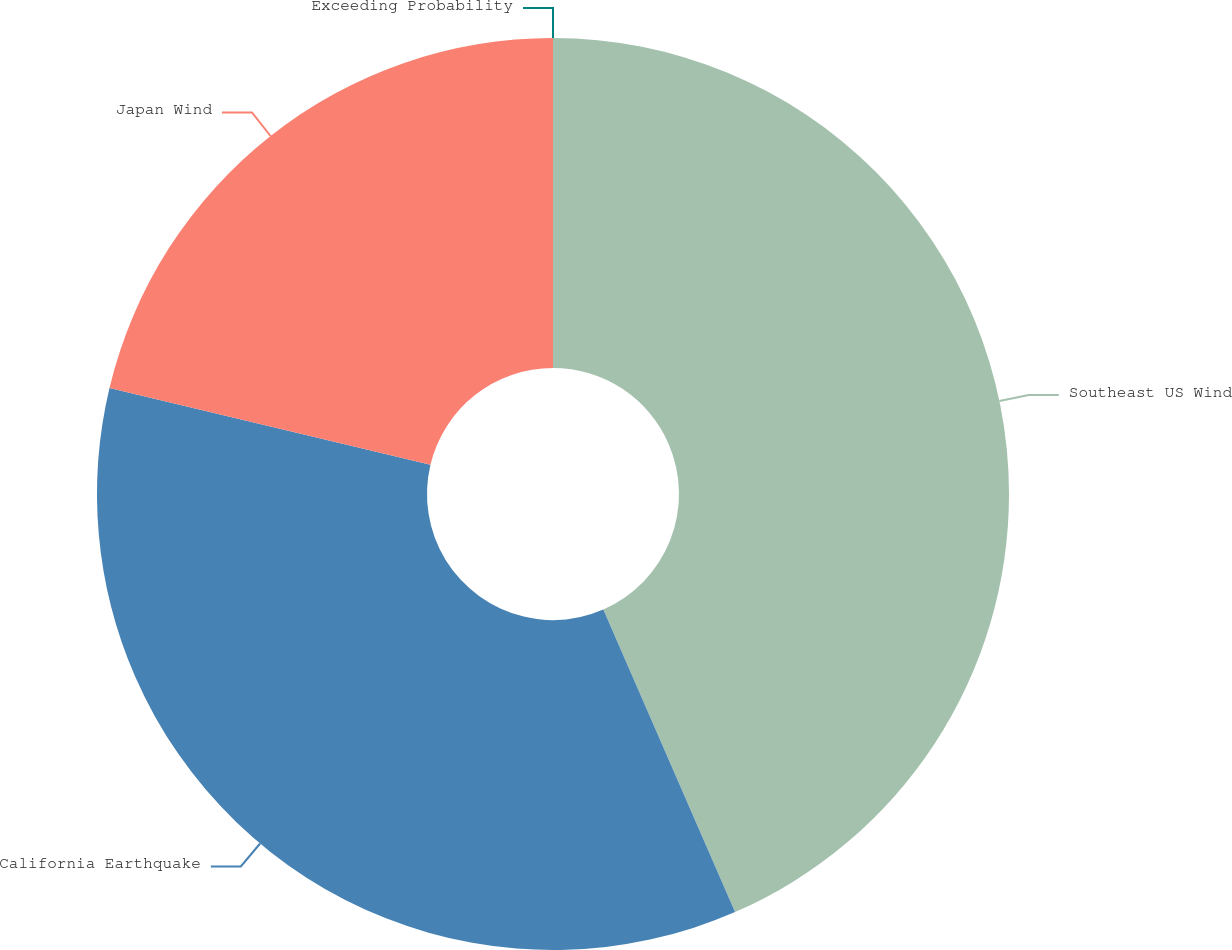Convert chart. <chart><loc_0><loc_0><loc_500><loc_500><pie_chart><fcel>Exceeding Probability<fcel>Southeast US Wind<fcel>California Earthquake<fcel>Japan Wind<nl><fcel>0.0%<fcel>43.46%<fcel>35.27%<fcel>21.26%<nl></chart> 